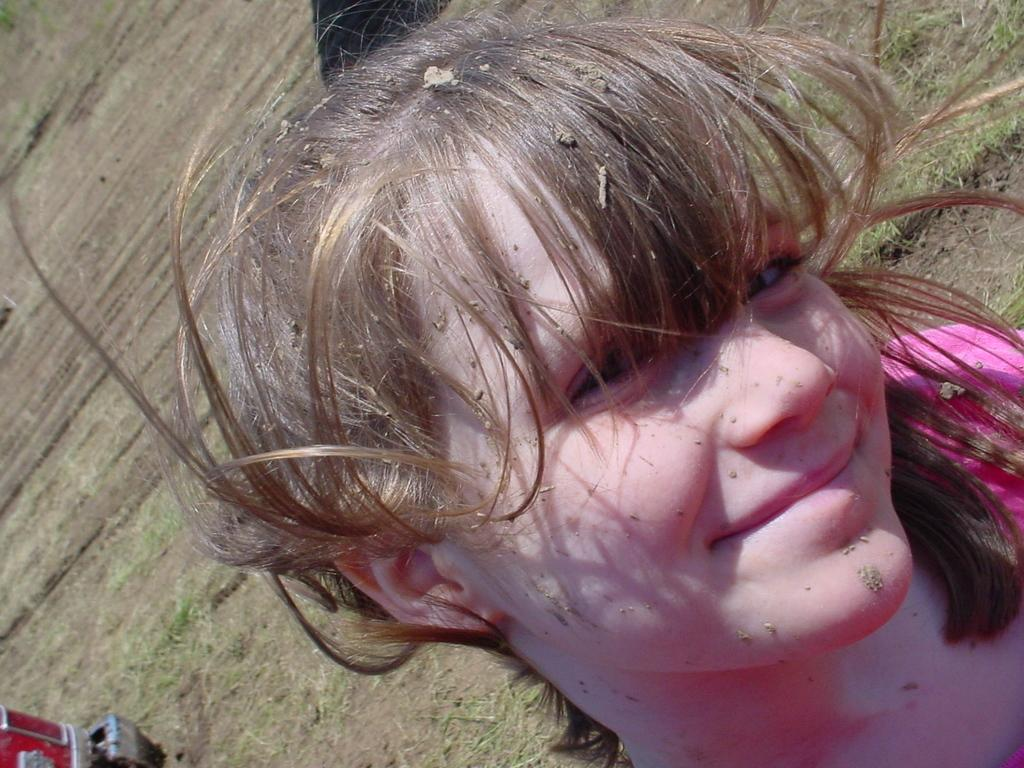Who is the main subject in the image? There is a girl in the image. What is the girl's facial expression in the image? The girl is smiling in the image. What is the girl wearing in the image? The girl is wearing a pink dress in the image. What is the condition of the girl's hair in the image? The girl has bangs in the image. What is the unusual aspect of the girl's appearance in the image? There is mud on the girl in the image. Where is the faucet located in the image? There is no faucet present in the image. What type of river can be seen in the background of the image? There is no river visible in the image. 